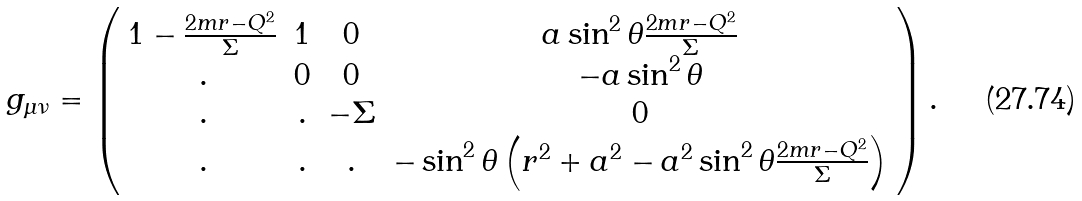<formula> <loc_0><loc_0><loc_500><loc_500>g _ { \mu \nu } = \left ( \begin{array} { c c c c } 1 - \frac { 2 m r - Q ^ { 2 } } { \Sigma } & 1 & 0 & a \sin ^ { 2 } { \theta } \frac { 2 m r - Q ^ { 2 } } { \Sigma } \\ . & 0 & 0 & - a \sin ^ { 2 } { \theta } \\ . & . & - \Sigma & 0 \\ . & . & . & - \sin ^ { 2 } { \theta } \left ( r ^ { 2 } + a ^ { 2 } - a ^ { 2 } \sin ^ { 2 } { \theta } \frac { 2 m r - Q ^ { 2 } } { \Sigma } \right ) \\ \end{array} \right ) .</formula> 